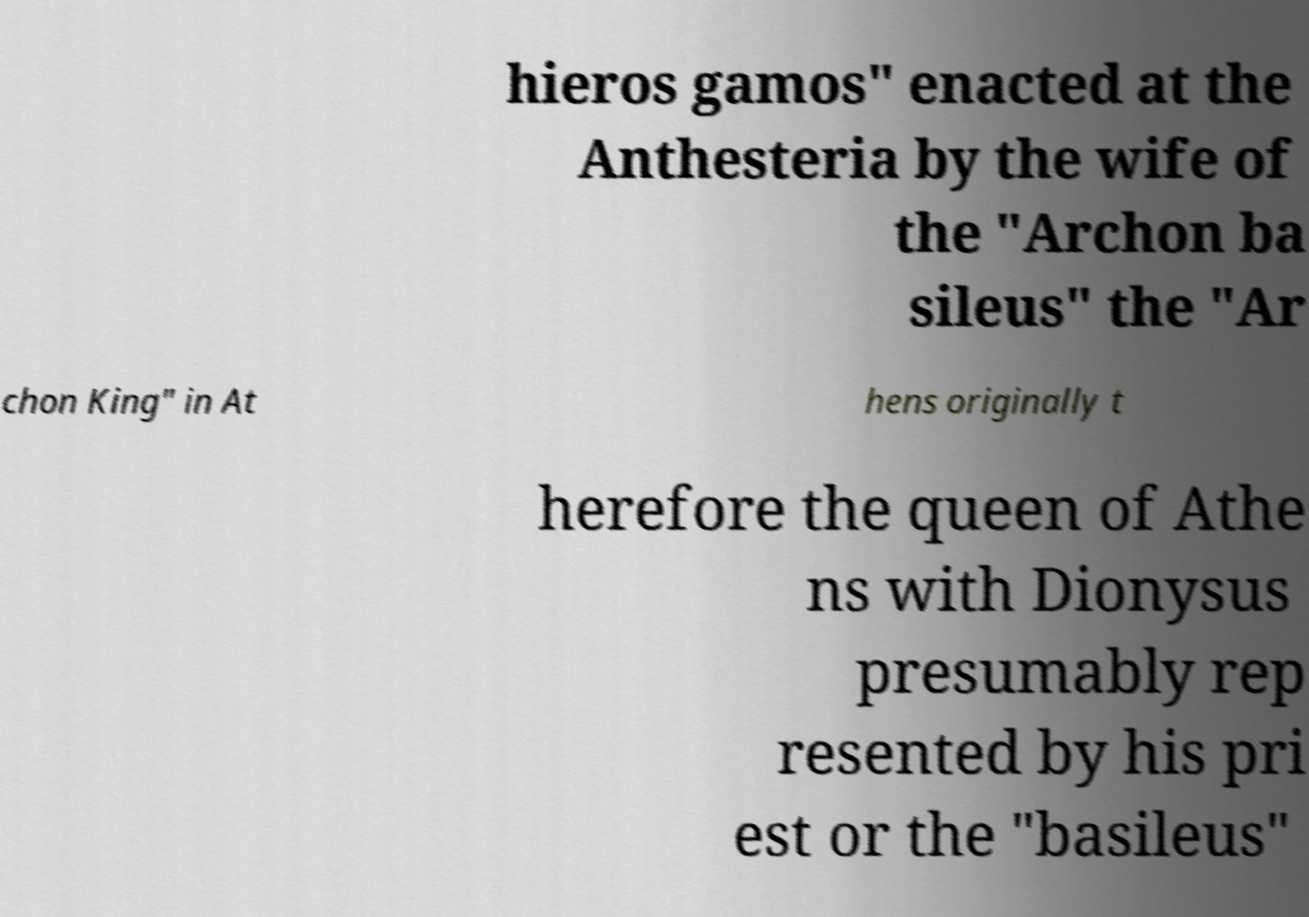I need the written content from this picture converted into text. Can you do that? hieros gamos" enacted at the Anthesteria by the wife of the "Archon ba sileus" the "Ar chon King" in At hens originally t herefore the queen of Athe ns with Dionysus presumably rep resented by his pri est or the "basileus" 